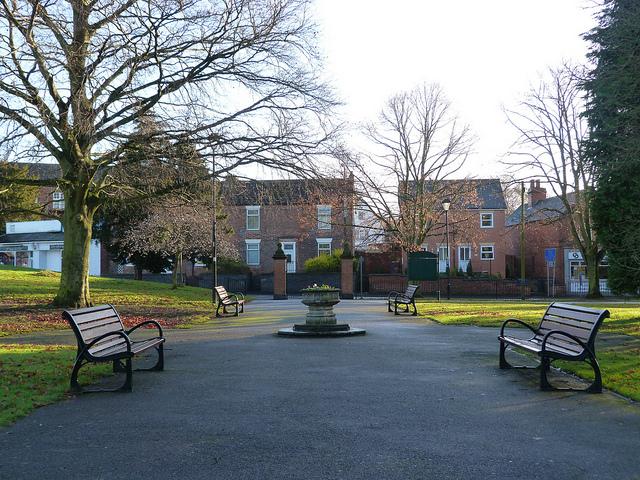Are there any leaves on the grass?
Be succinct. Yes. Can you see people?
Short answer required. No. How many benches are visible?
Quick response, please. 4. 